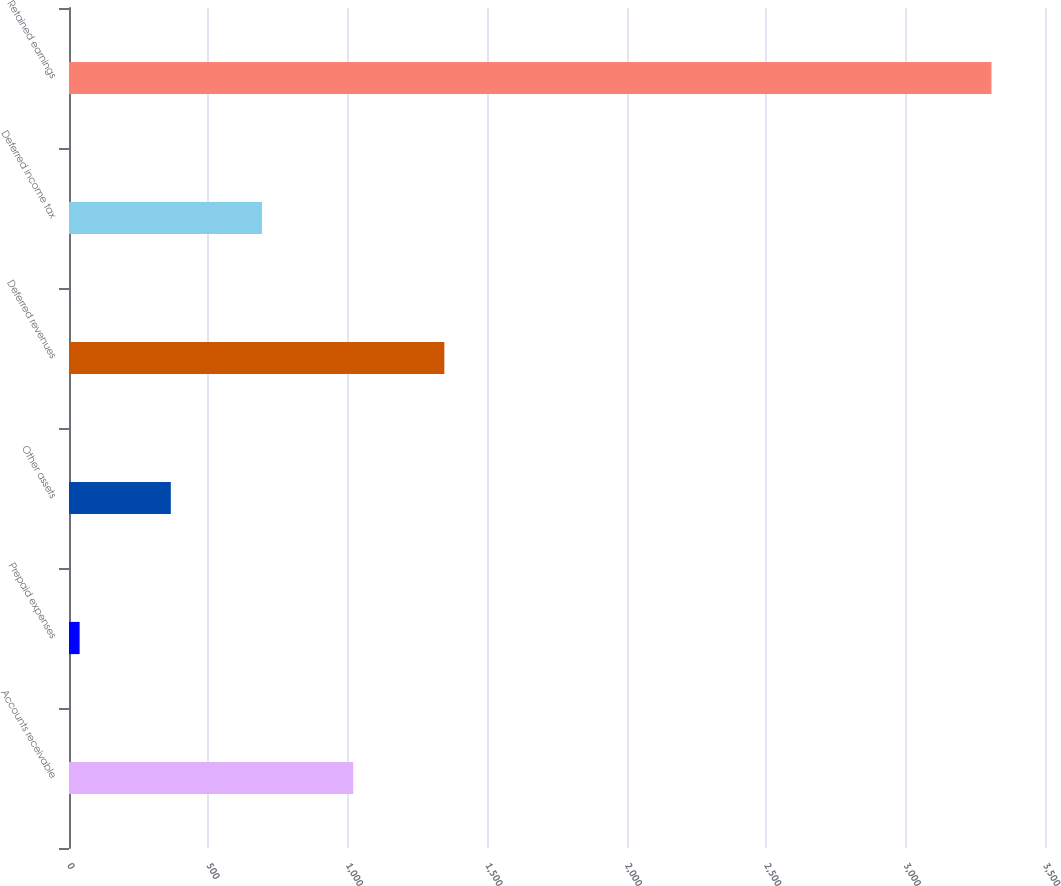<chart> <loc_0><loc_0><loc_500><loc_500><bar_chart><fcel>Accounts receivable<fcel>Prepaid expenses<fcel>Other assets<fcel>Deferred revenues<fcel>Deferred income tax<fcel>Retained earnings<nl><fcel>1019.07<fcel>38.1<fcel>365.09<fcel>1346.06<fcel>692.08<fcel>3308<nl></chart> 